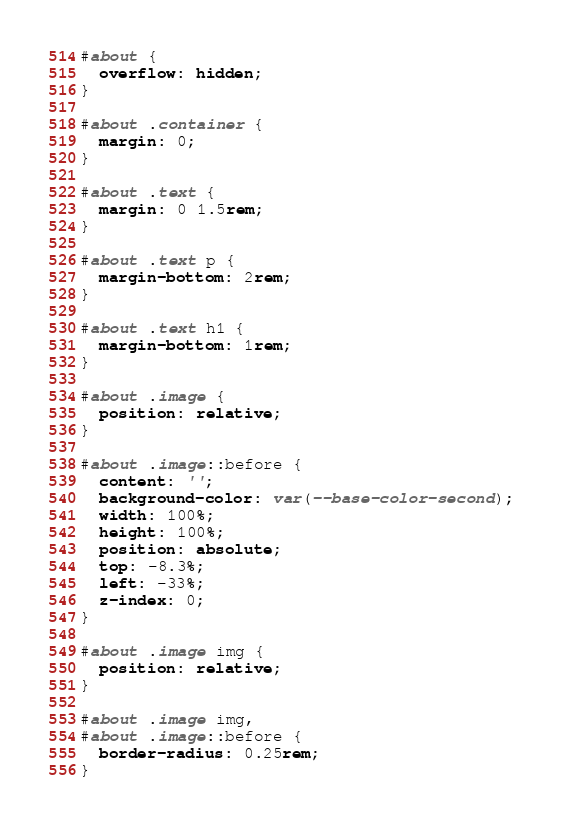Convert code to text. <code><loc_0><loc_0><loc_500><loc_500><_CSS_>#about {
  overflow: hidden;
}

#about .container {
  margin: 0;
}

#about .text {
  margin: 0 1.5rem;
}

#about .text p {
  margin-bottom: 2rem;
}

#about .text h1 {
  margin-bottom: 1rem;
}

#about .image {
  position: relative;
}

#about .image::before {
  content: '';
  background-color: var(--base-color-second);
  width: 100%;
  height: 100%;
  position: absolute;
  top: -8.3%;
  left: -33%;
  z-index: 0;
}

#about .image img {
  position: relative;
}

#about .image img,
#about .image::before {
  border-radius: 0.25rem;
}
</code> 